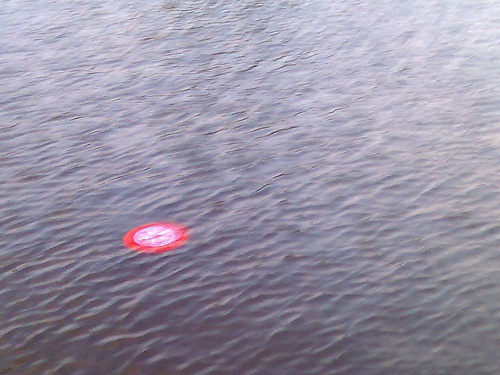Describe the objects in this image and their specific colors. I can see a frisbee in lightgray, violet, salmon, and lavender tones in this image. 